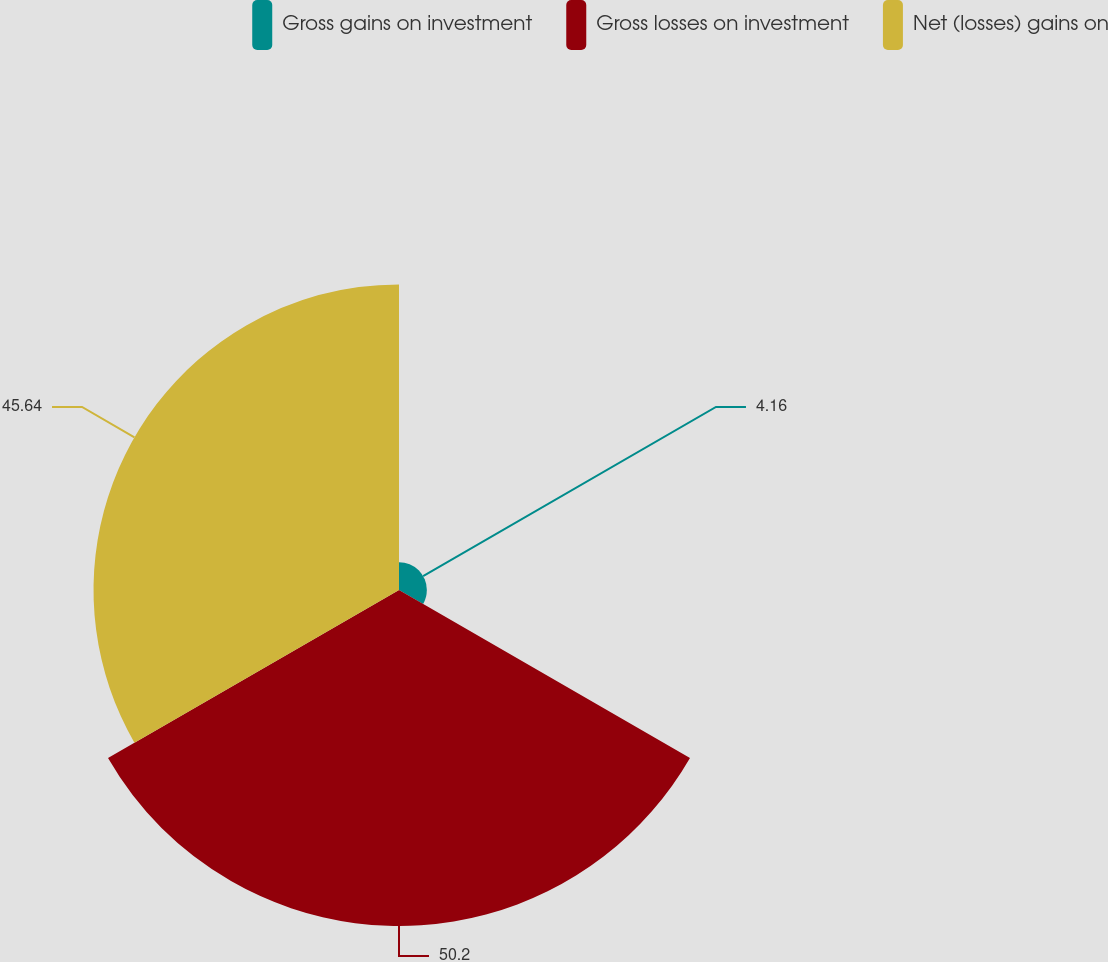<chart> <loc_0><loc_0><loc_500><loc_500><pie_chart><fcel>Gross gains on investment<fcel>Gross losses on investment<fcel>Net (losses) gains on<nl><fcel>4.16%<fcel>50.2%<fcel>45.64%<nl></chart> 